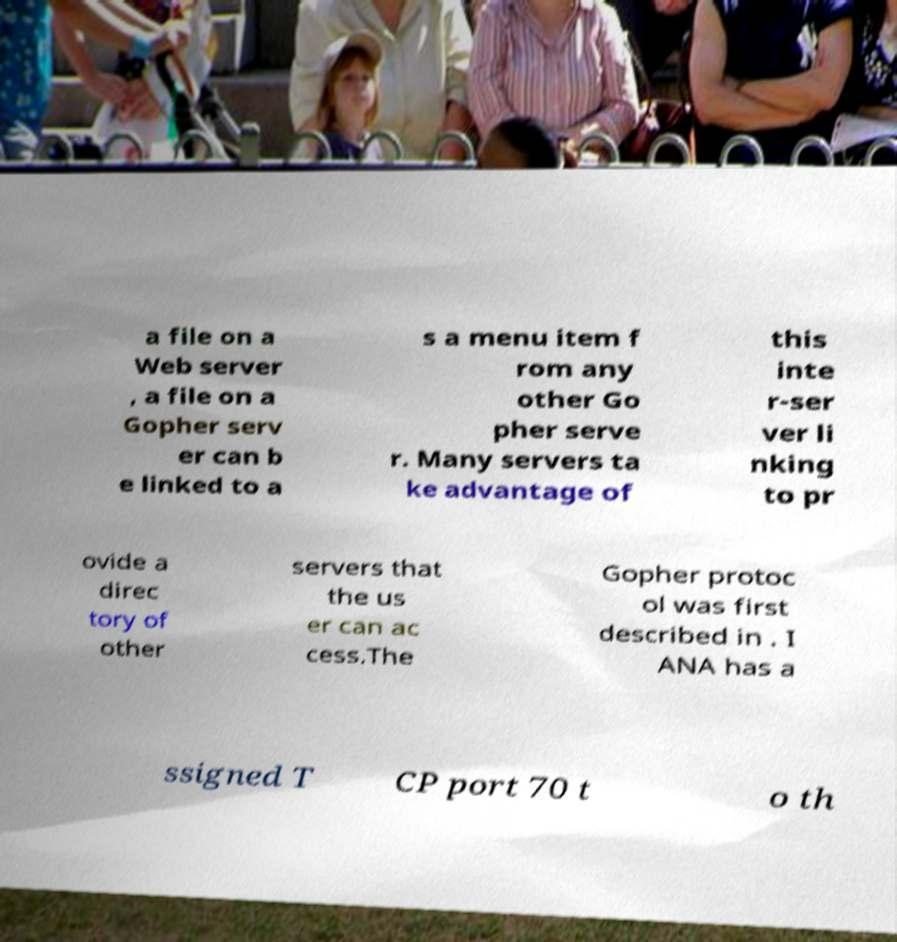Can you accurately transcribe the text from the provided image for me? a file on a Web server , a file on a Gopher serv er can b e linked to a s a menu item f rom any other Go pher serve r. Many servers ta ke advantage of this inte r-ser ver li nking to pr ovide a direc tory of other servers that the us er can ac cess.The Gopher protoc ol was first described in . I ANA has a ssigned T CP port 70 t o th 